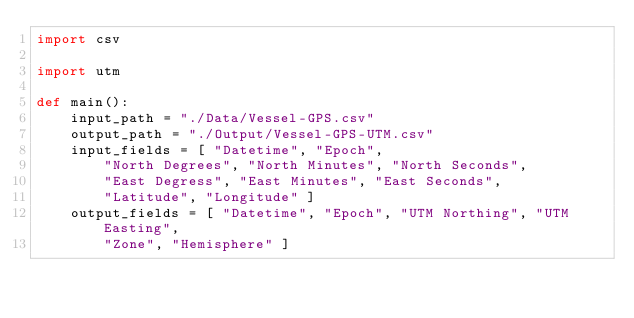<code> <loc_0><loc_0><loc_500><loc_500><_Python_>import csv

import utm

def main():
    input_path = "./Data/Vessel-GPS.csv"
    output_path = "./Output/Vessel-GPS-UTM.csv"
    input_fields = [ "Datetime", "Epoch", 
        "North Degrees", "North Minutes", "North Seconds",
        "East Degress", "East Minutes", "East Seconds",
        "Latitude", "Longitude" ]
    output_fields = [ "Datetime", "Epoch", "UTM Northing", "UTM Easting", 
        "Zone", "Hemisphere" ]
</code> 